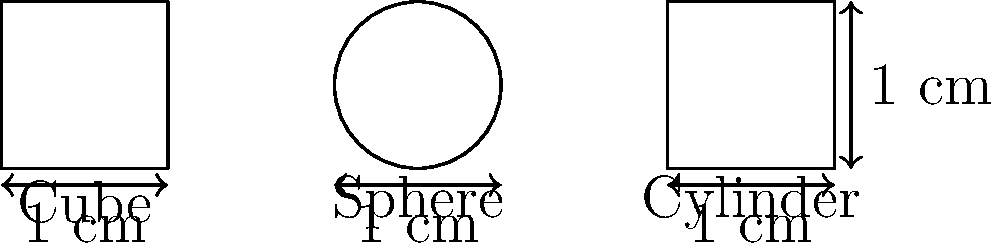A pharmaceutical company is developing a new drug delivery system and needs to optimize the surface area-to-volume ratio for better drug absorption. They are considering three different shapes for their nanoparticles: a cube, a sphere, and a cylinder, each with a volume of 1 cm³. Which shape would provide the highest surface area-to-volume ratio, potentially leading to the most efficient drug absorption? To solve this problem, we need to calculate the surface area-to-volume ratio for each shape:

1. Cube:
   - Volume: $V = s^3 = 1$ cm³, so side length $s = 1$ cm
   - Surface Area: $SA = 6s^2 = 6$ cm²
   - Surface Area-to-Volume Ratio: $\frac{SA}{V} = \frac{6}{1} = 6$ cm⁻¹

2. Sphere:
   - Volume: $V = \frac{4}{3}\pi r^3 = 1$ cm³, so radius $r = (\frac{3}{4\pi})^{\frac{1}{3}} \approx 0.62$ cm
   - Surface Area: $SA = 4\pi r^2 = 4\pi (\frac{3}{4\pi})^{\frac{2}{3}} \approx 4.84$ cm²
   - Surface Area-to-Volume Ratio: $\frac{SA}{V} = \frac{4.84}{1} = 4.84$ cm⁻¹

3. Cylinder:
   - Volume: $V = \pi r^2 h = 1$ cm³
   - Assuming height equals diameter for optimization: $h = 2r$
   - $\pi r^2 (2r) = 1$, so $r = (\frac{1}{2\pi})^{\frac{1}{3}} \approx 0.54$ cm and $h \approx 1.08$ cm
   - Surface Area: $SA = 2\pi r^2 + 2\pi rh = 2\pi r^2 + 4\pi r^2 = 6\pi r^2 \approx 5.54$ cm²
   - Surface Area-to-Volume Ratio: $\frac{SA}{V} = \frac{5.54}{1} = 5.54$ cm⁻¹

Comparing the ratios:
Cube: 6 cm⁻¹
Sphere: 4.84 cm⁻¹
Cylinder: 5.54 cm⁻¹

The cube has the highest surface area-to-volume ratio among these shapes.
Answer: Cube 